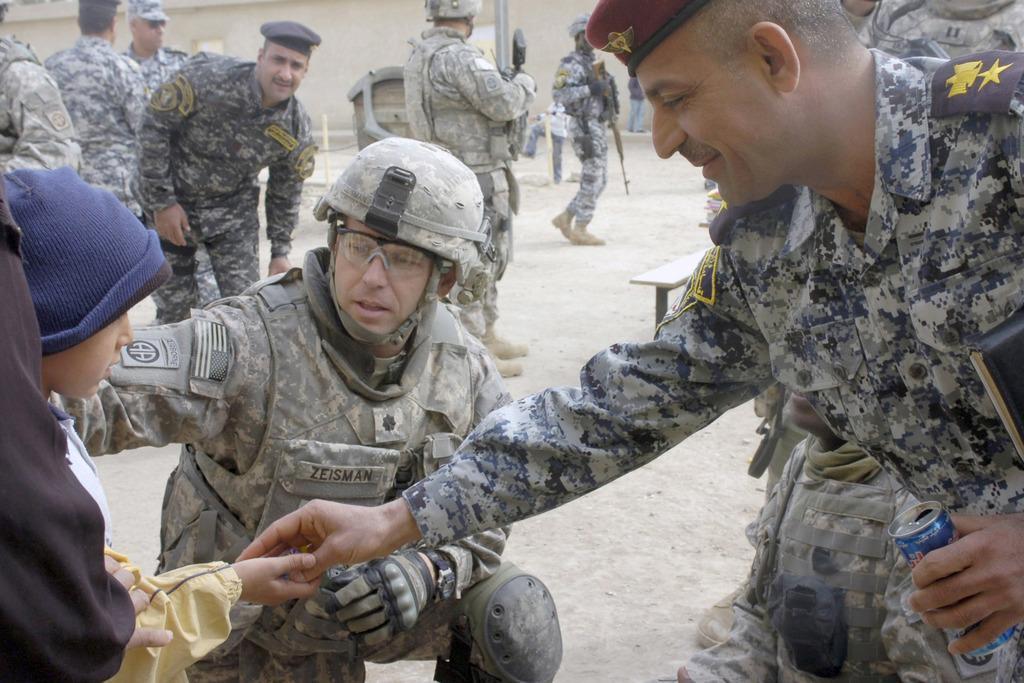Could you give a brief overview of what you see in this image? Here men are standing. This is can, gun and helmet. 